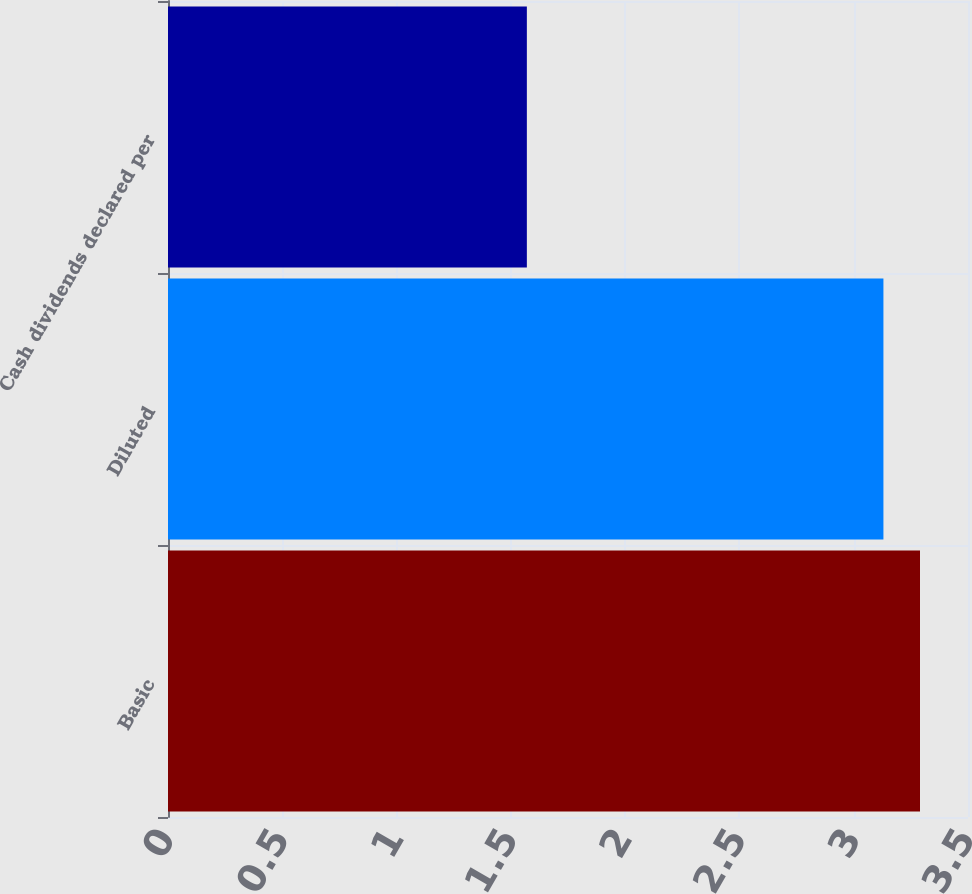Convert chart. <chart><loc_0><loc_0><loc_500><loc_500><bar_chart><fcel>Basic<fcel>Diluted<fcel>Cash dividends declared per<nl><fcel>3.29<fcel>3.13<fcel>1.57<nl></chart> 